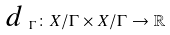<formula> <loc_0><loc_0><loc_500><loc_500>\emph { d } _ { \Gamma } \colon X / \Gamma \times X / \Gamma \to \mathbb { R }</formula> 